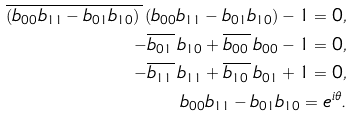<formula> <loc_0><loc_0><loc_500><loc_500>\overline { ( b _ { 0 0 } b _ { 1 1 } - b _ { 0 1 } b _ { 1 0 } ) \, } \, ( b _ { 0 0 } b _ { 1 1 } - b _ { 0 1 } b _ { 1 0 } ) - 1 = 0 , \\ - \overline { b _ { 0 1 } \, } \, b _ { 1 0 } + \overline { b _ { 0 0 } \, } \, b _ { 0 0 } - 1 = 0 , \\ - \overline { b _ { 1 1 } \, } \, b _ { 1 1 } + \overline { b _ { 1 0 } \, } \, b _ { 0 1 } + 1 = 0 , \\ b _ { 0 0 } b _ { 1 1 } - b _ { 0 1 } b _ { 1 0 } = e ^ { i \theta } .</formula> 